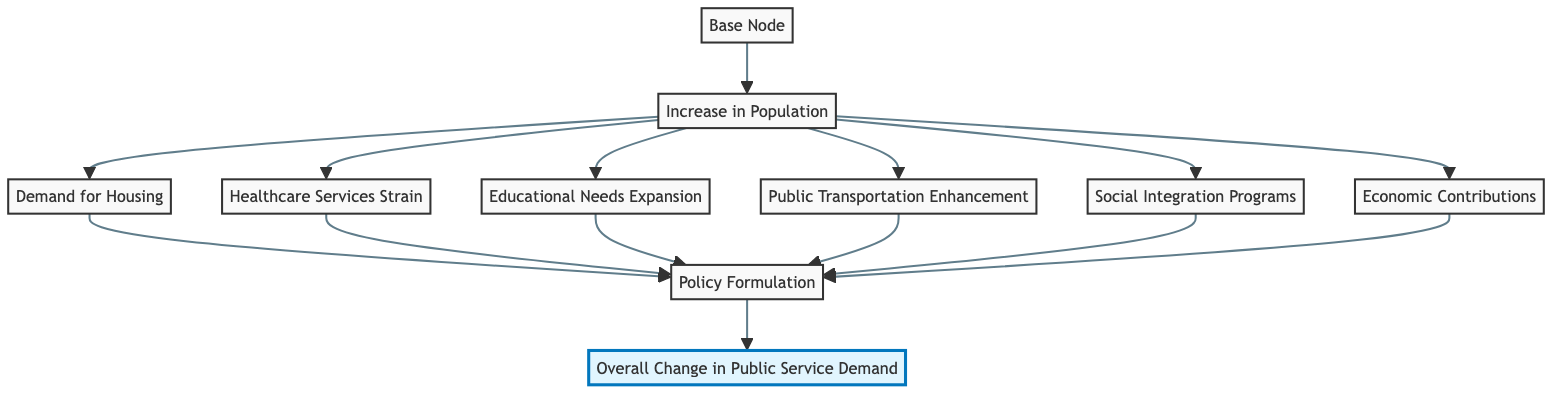What is the starting point of the diagram? The starting point, represented by the "Base Node," signifies the initial impact of migration on public service demand.
Answer: Base Node How many nodes follow the "Increase in Population" node? The "Increase in Population" leads to six subsequent nodes: "Demand for Housing," "Healthcare Services Strain," "Educational Needs Expansion," "Public Transportation Enhancement," "Social Integration Programs," and "Economic Contributions."
Answer: 6 Which node is directly connected to "Policy Formulation"? The "Policy Formulation" node is directly connected to the six preceding nodes, which are the demands created by the "Increase in Population."
Answer: Demand for Housing, Healthcare Services Strain, Educational Needs Expansion, Public Transportation Enhancement, Social Integration Programs, Economic Contributions What is the final outcome represented in the diagram? The final outcome of the flow chart is encapsulated in the node labeled "Overall Change in Public Service Demand," which reflects the cumulative effects of all previous nodes.
Answer: Overall Change in Public Service Demand How many edges are there from "Increase in Population"? The "Increase in Population" node has six outgoing edges leading to the six nodes of demand created by the increased population.
Answer: 6 What is the relationship between "Social Integration Programs" and "Overall Change in Public Service Demand"? "Social Integration Programs" contributes to the overall public service demand through its connection to "Policy Formulation," which integrates all previous demands into one overall change.
Answer: Contributes Which node depicts the strain on healthcare services? The node that depicts the strain on healthcare services is labeled "Healthcare Services Strain," which indicates the increased need due to population growth.
Answer: Healthcare Services Strain How does "Economic Contributions" affect "Policy Formulation"? "Economic Contributions" influences "Policy Formulation," as the economic input from migrant participation is a factor that city administrations consider when addressing urban service demands.
Answer: Influences What role does the "Base Node" play in the function described by the diagram? The "Base Node" initiates the flow of the diagram, setting the stage for subsequent changes in public service demand resulting from migration patterns.
Answer: Initiates flow 